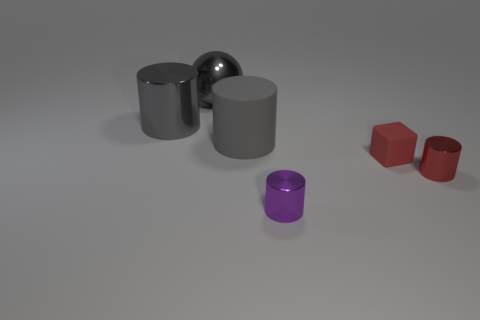The metal object that is in front of the tiny thing on the right side of the matte thing that is to the right of the gray rubber object is what shape? The metal object in question is cylindrical in shape, featuring a smooth reflective surface indicative of its metallic nature. Its round edges and symmetrical form confirm the cylindrical description. 